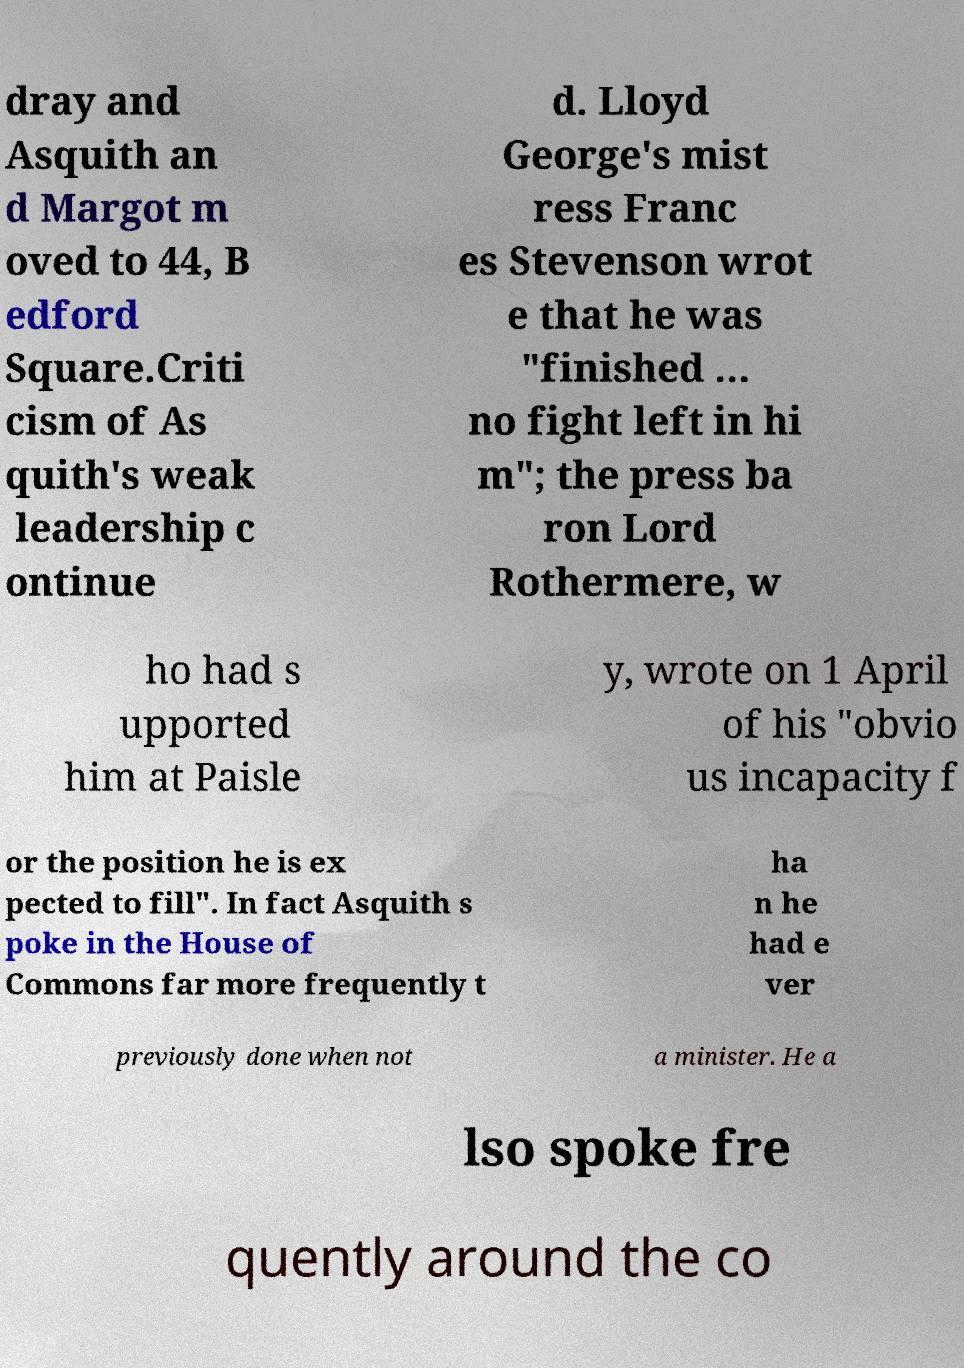For documentation purposes, I need the text within this image transcribed. Could you provide that? dray and Asquith an d Margot m oved to 44, B edford Square.Criti cism of As quith's weak leadership c ontinue d. Lloyd George's mist ress Franc es Stevenson wrot e that he was "finished … no fight left in hi m"; the press ba ron Lord Rothermere, w ho had s upported him at Paisle y, wrote on 1 April of his "obvio us incapacity f or the position he is ex pected to fill". In fact Asquith s poke in the House of Commons far more frequently t ha n he had e ver previously done when not a minister. He a lso spoke fre quently around the co 